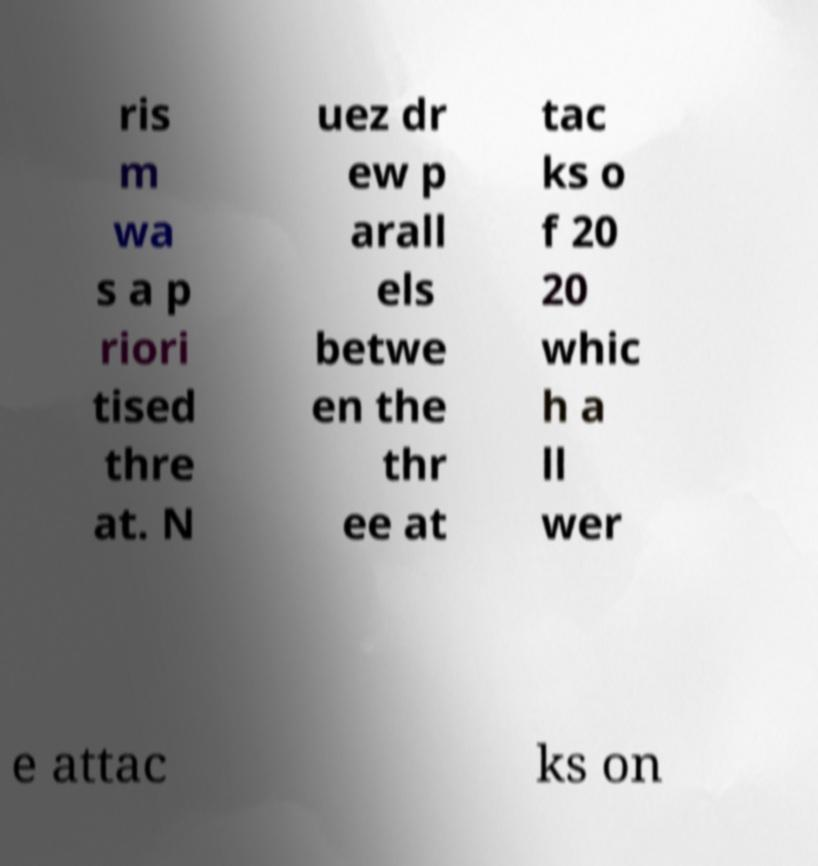There's text embedded in this image that I need extracted. Can you transcribe it verbatim? ris m wa s a p riori tised thre at. N uez dr ew p arall els betwe en the thr ee at tac ks o f 20 20 whic h a ll wer e attac ks on 